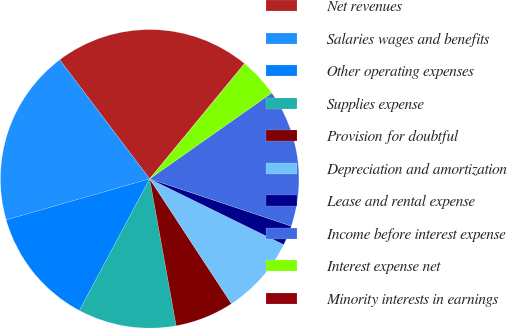<chart> <loc_0><loc_0><loc_500><loc_500><pie_chart><fcel>Net revenues<fcel>Salaries wages and benefits<fcel>Other operating expenses<fcel>Supplies expense<fcel>Provision for doubtful<fcel>Depreciation and amortization<fcel>Lease and rental expense<fcel>Income before interest expense<fcel>Interest expense net<fcel>Minority interests in earnings<nl><fcel>21.25%<fcel>19.13%<fcel>12.76%<fcel>10.64%<fcel>6.39%<fcel>8.51%<fcel>2.14%<fcel>14.88%<fcel>4.27%<fcel>0.02%<nl></chart> 